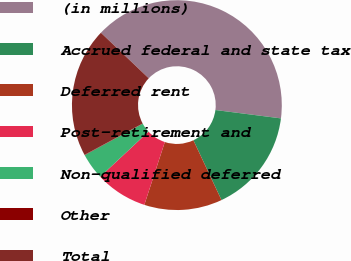<chart> <loc_0><loc_0><loc_500><loc_500><pie_chart><fcel>(in millions)<fcel>Accrued federal and state tax<fcel>Deferred rent<fcel>Post-retirement and<fcel>Non-qualified deferred<fcel>Other<fcel>Total<nl><fcel>39.91%<fcel>15.99%<fcel>12.01%<fcel>8.02%<fcel>4.04%<fcel>0.05%<fcel>19.98%<nl></chart> 